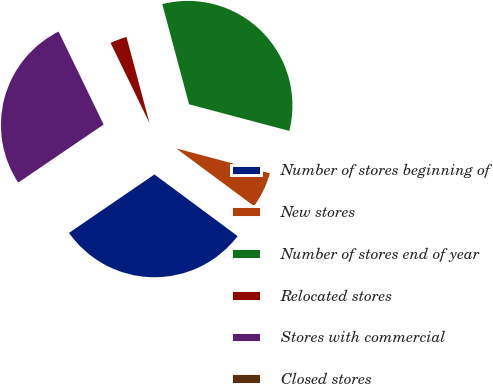<chart> <loc_0><loc_0><loc_500><loc_500><pie_chart><fcel>Number of stores beginning of<fcel>New stores<fcel>Number of stores end of year<fcel>Relocated stores<fcel>Stores with commercial<fcel>Closed stores<nl><fcel>30.3%<fcel>6.02%<fcel>33.29%<fcel>3.03%<fcel>27.32%<fcel>0.04%<nl></chart> 